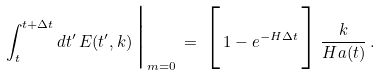Convert formula to latex. <formula><loc_0><loc_0><loc_500><loc_500>\int _ { t } ^ { t + \Delta t } d t ^ { \prime } \, E ( t ^ { \prime } , k ) \, \Big | _ { m = 0 } \, = \, \Big [ \, 1 - e ^ { - H \Delta t } \, \Big ] \, \frac { k } { H a ( t ) } \, .</formula> 